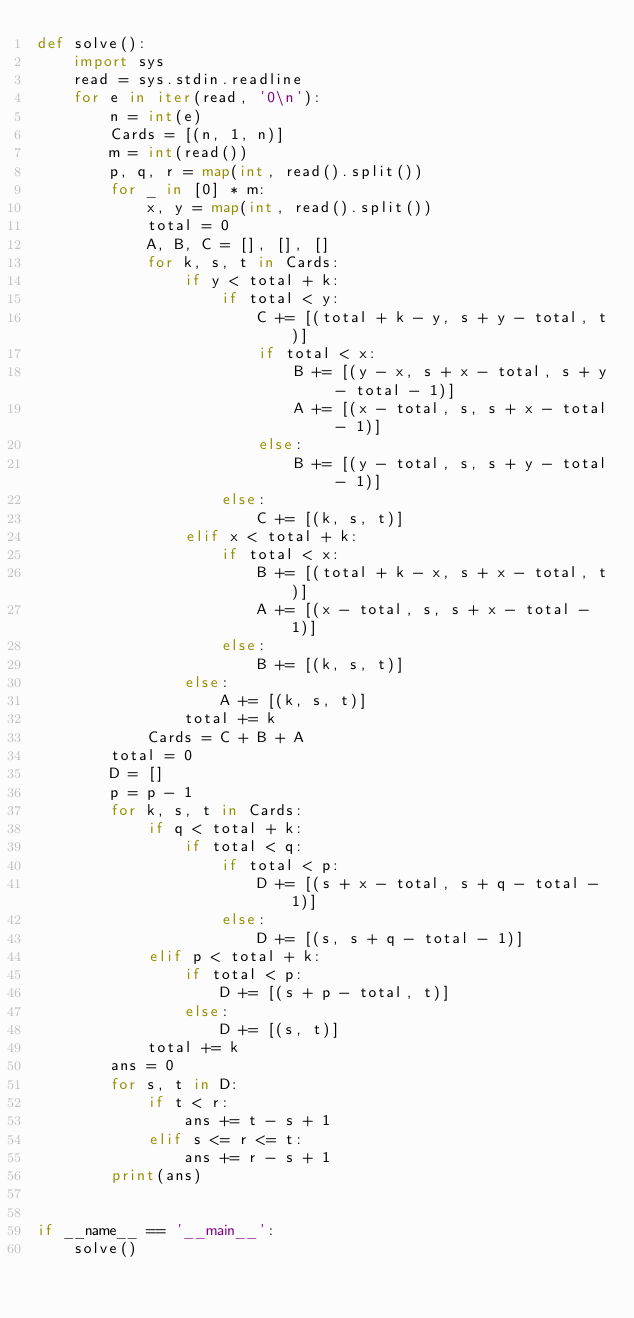Convert code to text. <code><loc_0><loc_0><loc_500><loc_500><_Python_>def solve():
    import sys
    read = sys.stdin.readline
    for e in iter(read, '0\n'):
        n = int(e)
        Cards = [(n, 1, n)]
        m = int(read())
        p, q, r = map(int, read().split())
        for _ in [0] * m:
            x, y = map(int, read().split())
            total = 0
            A, B, C = [], [], []
            for k, s, t in Cards:
                if y < total + k:
                    if total < y:
                        C += [(total + k - y, s + y - total, t)]
                        if total < x:
                            B += [(y - x, s + x - total, s + y - total - 1)]
                            A += [(x - total, s, s + x - total - 1)]
                        else:
                            B += [(y - total, s, s + y - total - 1)]
                    else:
                        C += [(k, s, t)]
                elif x < total + k:
                    if total < x:
                        B += [(total + k - x, s + x - total, t)]
                        A += [(x - total, s, s + x - total - 1)]
                    else:
                        B += [(k, s, t)]
                else:
                    A += [(k, s, t)]
                total += k
            Cards = C + B + A
        total = 0
        D = []
        p = p - 1
        for k, s, t in Cards:
            if q < total + k:
                if total < q:
                    if total < p:
                        D += [(s + x - total, s + q - total - 1)]
                    else:
                        D += [(s, s + q - total - 1)]
            elif p < total + k:
                if total < p:
                    D += [(s + p - total, t)]
                else:
                    D += [(s, t)]
            total += k
        ans = 0
        for s, t in D:
            if t < r:
                ans += t - s + 1
            elif s <= r <= t:
                ans += r - s + 1
        print(ans)


if __name__ == '__main__':
    solve()
</code> 